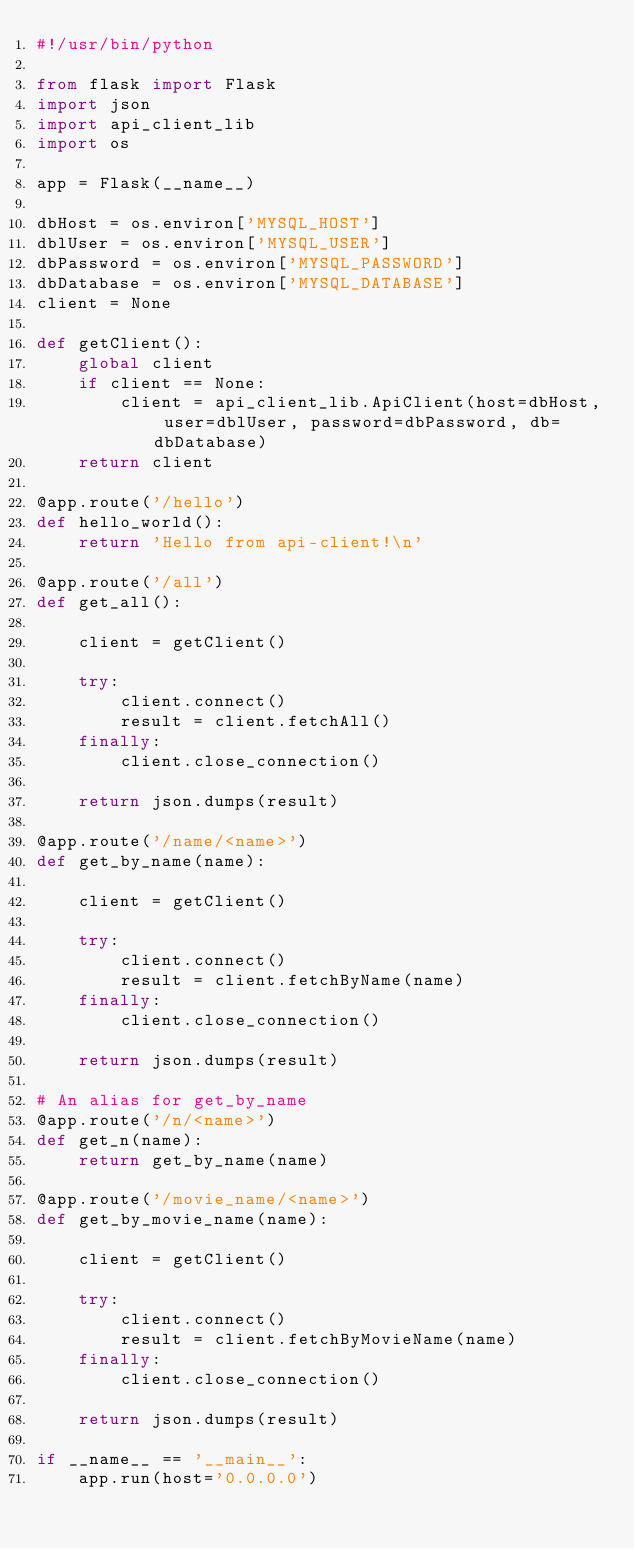<code> <loc_0><loc_0><loc_500><loc_500><_Python_>#!/usr/bin/python

from flask import Flask
import json
import api_client_lib
import os

app = Flask(__name__)

dbHost = os.environ['MYSQL_HOST']
dblUser = os.environ['MYSQL_USER']
dbPassword = os.environ['MYSQL_PASSWORD']
dbDatabase = os.environ['MYSQL_DATABASE']
client = None

def getClient():
    global client
    if client == None:
        client = api_client_lib.ApiClient(host=dbHost, user=dblUser, password=dbPassword, db=dbDatabase)
    return client

@app.route('/hello')
def hello_world():
    return 'Hello from api-client!\n'

@app.route('/all')
def get_all():
    
    client = getClient()
  
    try:
        client.connect()
        result = client.fetchAll()
    finally:
        client.close_connection()
    
    return json.dumps(result)

@app.route('/name/<name>')
def get_by_name(name):

    client = getClient()
  
    try:
        client.connect()
        result = client.fetchByName(name)
    finally:
        client.close_connection()
    
    return json.dumps(result)

# An alias for get_by_name
@app.route('/n/<name>')
def get_n(name):
    return get_by_name(name)

@app.route('/movie_name/<name>')
def get_by_movie_name(name):

    client = getClient()
  
    try:
        client.connect()
        result = client.fetchByMovieName(name)
    finally:
        client.close_connection()
    
    return json.dumps(result)

if __name__ == '__main__':
    app.run(host='0.0.0.0')</code> 